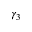<formula> <loc_0><loc_0><loc_500><loc_500>\gamma _ { 3 }</formula> 